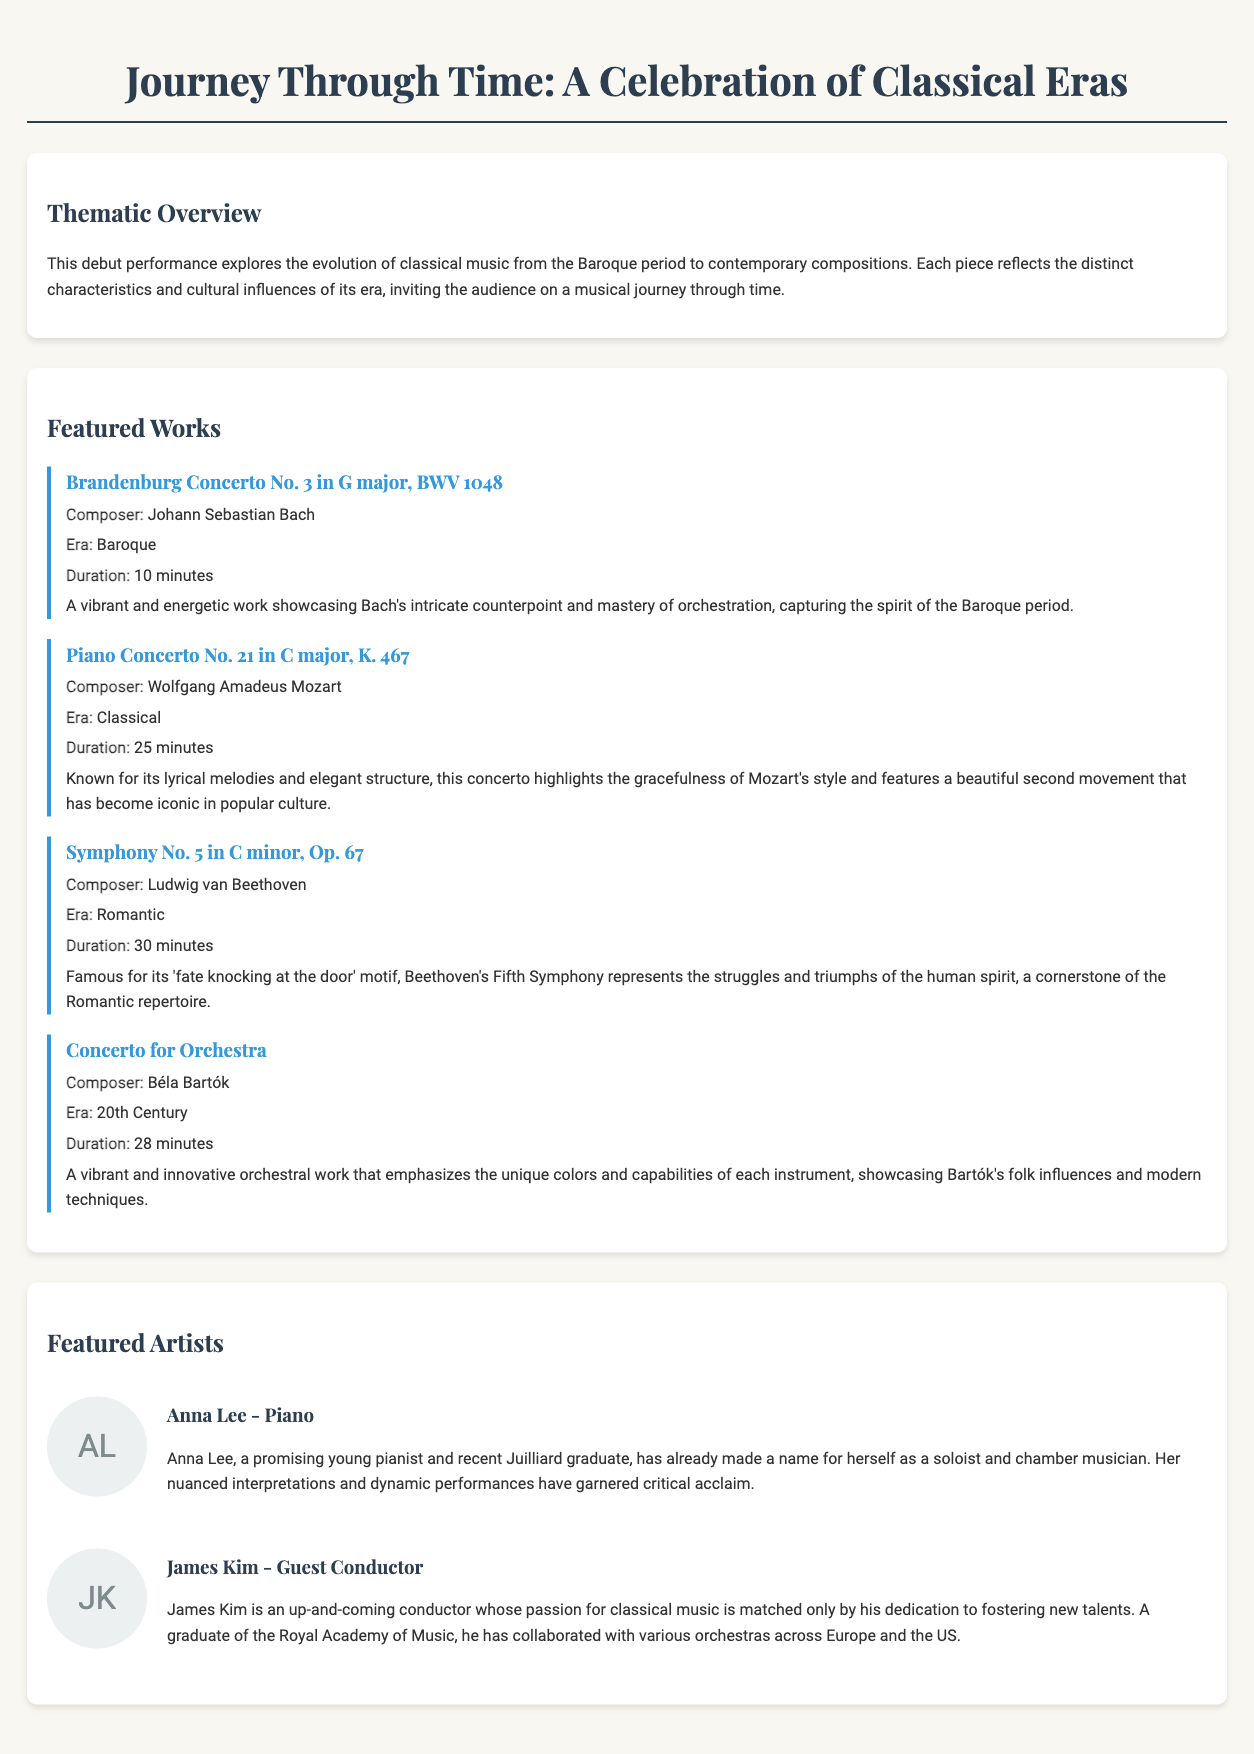What is the title of the concert program? The title of the concert program is prominently displayed at the top of the document.
Answer: Journey Through Time: A Celebration of Classical Eras Who is the composer of the Brandenburg Concerto No. 3? The composer's name is mentioned alongside the featured work.
Answer: Johann Sebastian Bach How many minutes is the duration of Beethoven's Symphony No. 5? The duration of the work is explicitly listed in the featured works section.
Answer: 30 minutes What era is associated with Béla Bartók's Concerto for Orchestra? This information is provided in the featured works section alongside each work.
Answer: 20th Century Who is the guest conductor for the performance? The guest conductor's name is provided in the featured artists section.
Answer: James Kim What is Anna Lee's role in the concert? Her role is mentioned in the biographies of the featured artists.
Answer: Piano Which composer is known for their lyrical melodies and elegant structure? This statement pertains to the description of a specific featured work in the document.
Answer: Wolfgang Amadeus Mozart What educational institution did James Kim graduate from? This detail is found in the biography of the guest conductor.
Answer: Royal Academy of Music How many featured works are listed in the document? The number can be counted from the "Featured Works" section.
Answer: Four 